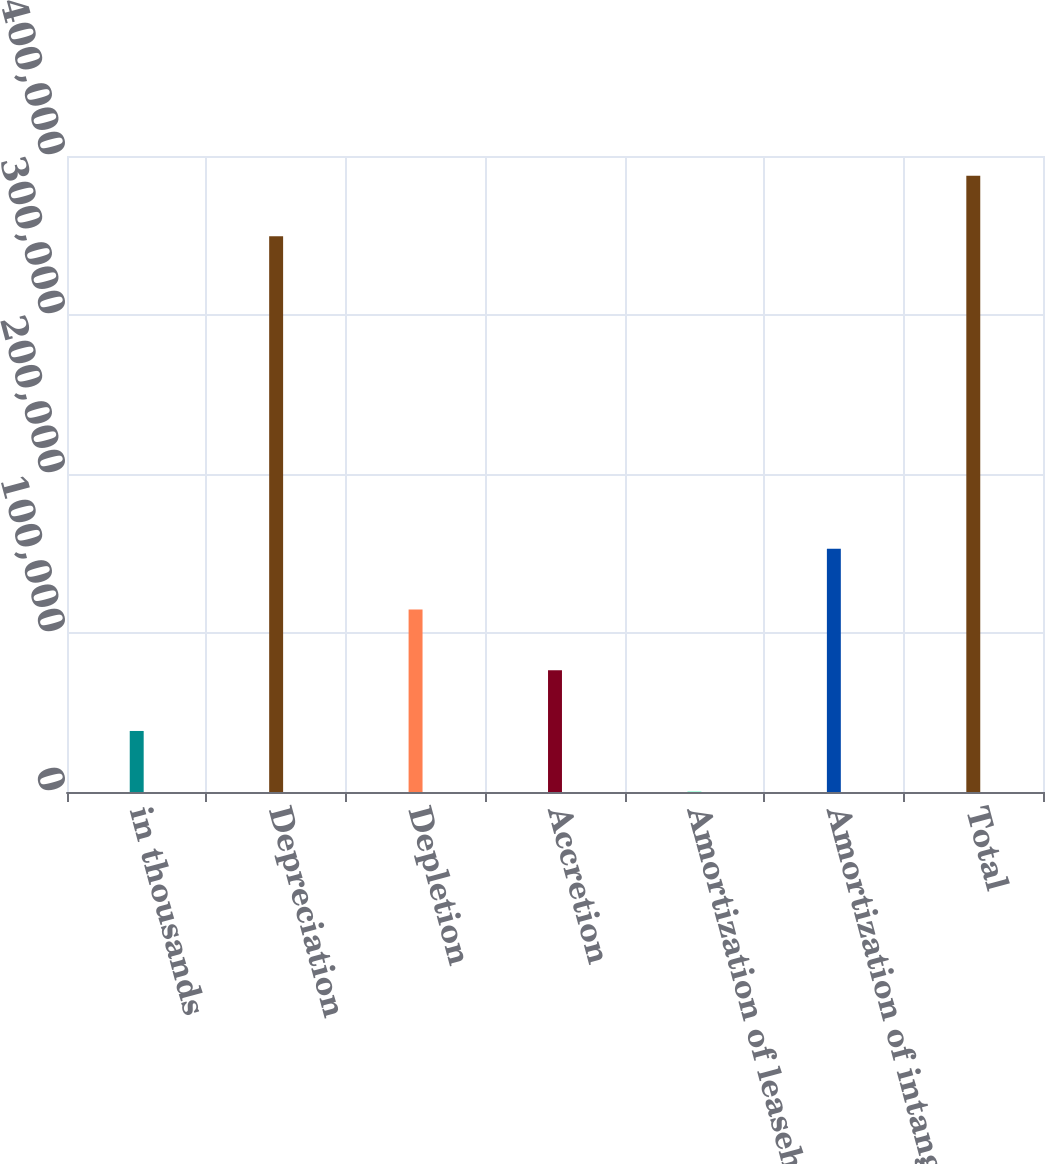<chart> <loc_0><loc_0><loc_500><loc_500><bar_chart><fcel>in thousands<fcel>Depreciation<fcel>Depletion<fcel>Accretion<fcel>Amortization of leaseholds and<fcel>Amortization of intangibles<fcel>Total<nl><fcel>38384.8<fcel>349460<fcel>114764<fcel>76574.6<fcel>195<fcel>152954<fcel>387650<nl></chart> 